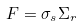<formula> <loc_0><loc_0><loc_500><loc_500>F = \sigma _ { s } \Sigma _ { r }</formula> 